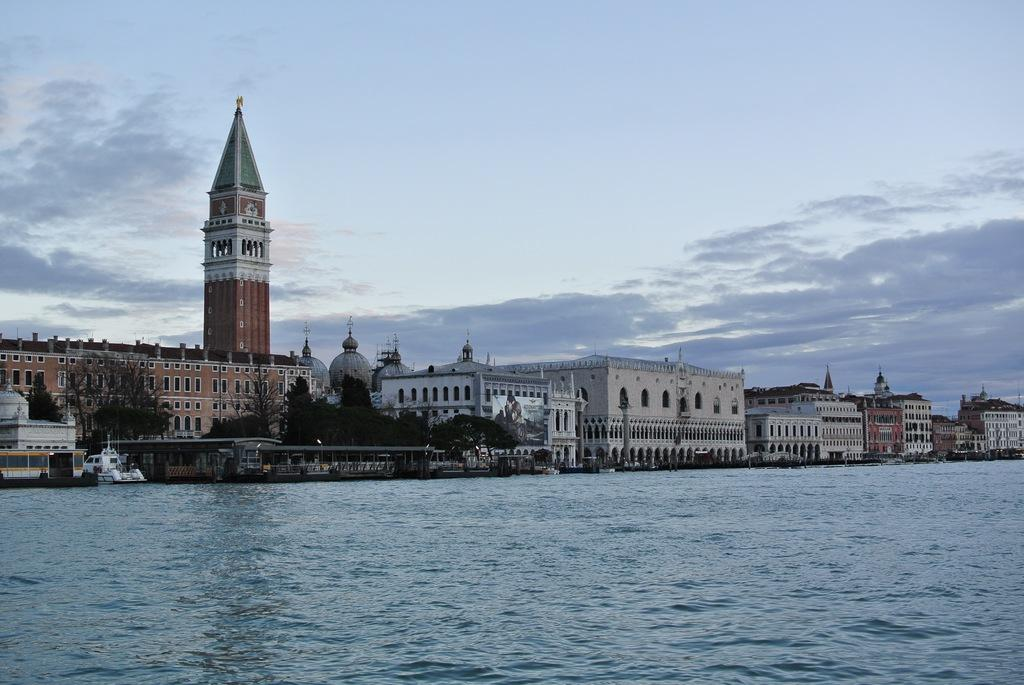What can be seen in the center of the image? There are buildings and trees in the center of the image. What is located at the bottom of the image? There is water at the bottom of the image. What type of transportation can be seen on the road? Vehicles are visible on the road. What is visible in the background of the image? There is sky visible in the background of the image. What arithmetic problem is being solved by the wave in the image? There is no wave or arithmetic problem present in the image. What observation can be made about the buildings in the image? The provided facts do not mention any specific observation about the buildings, so we cannot answer this question based on the given information. 